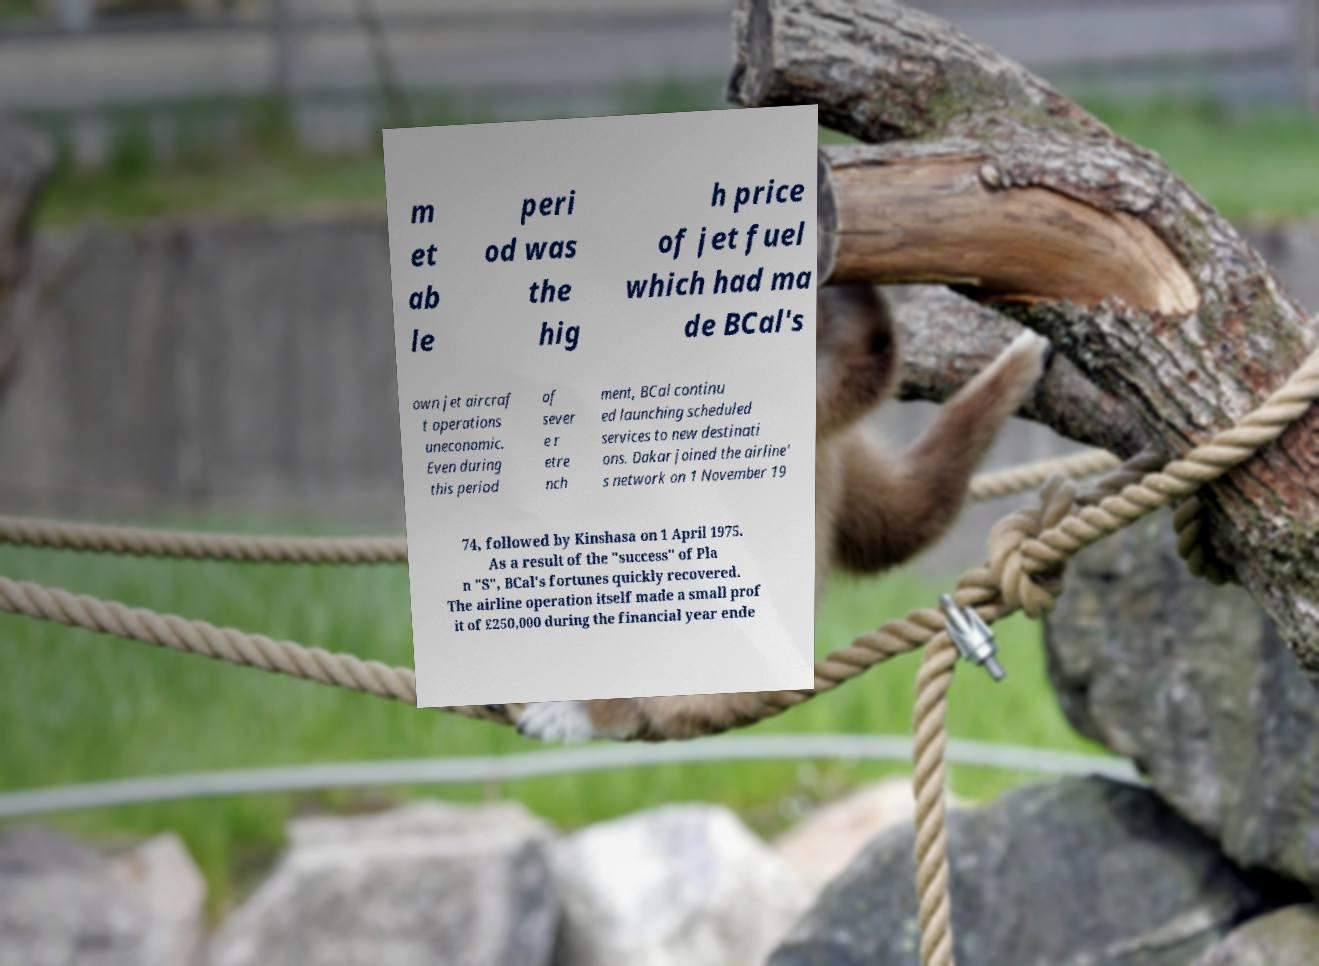For documentation purposes, I need the text within this image transcribed. Could you provide that? m et ab le peri od was the hig h price of jet fuel which had ma de BCal's own jet aircraf t operations uneconomic. Even during this period of sever e r etre nch ment, BCal continu ed launching scheduled services to new destinati ons. Dakar joined the airline' s network on 1 November 19 74, followed by Kinshasa on 1 April 1975. As a result of the "success" of Pla n "S", BCal's fortunes quickly recovered. The airline operation itself made a small prof it of £250,000 during the financial year ende 